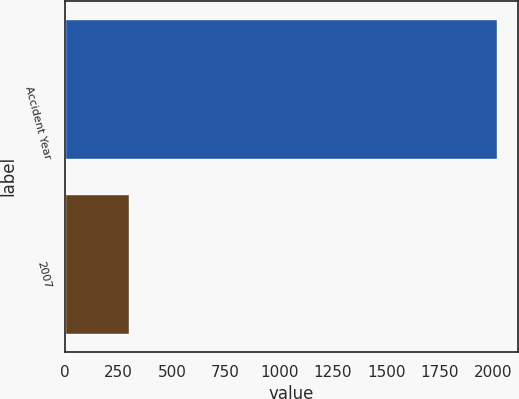Convert chart to OTSL. <chart><loc_0><loc_0><loc_500><loc_500><bar_chart><fcel>Accident Year<fcel>2007<nl><fcel>2016<fcel>297<nl></chart> 